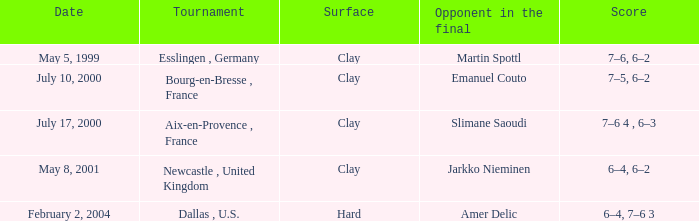What is the outcome of the competition played on clay surface on may 5, 1999? 7–6, 6–2. 